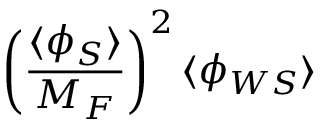Convert formula to latex. <formula><loc_0><loc_0><loc_500><loc_500>\left ( \frac { \langle \phi _ { S } \rangle } { M _ { F } } \right ) ^ { 2 } \langle \phi _ { W S } \rangle</formula> 